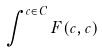Convert formula to latex. <formula><loc_0><loc_0><loc_500><loc_500>\int ^ { c \in C } F ( c , c )</formula> 